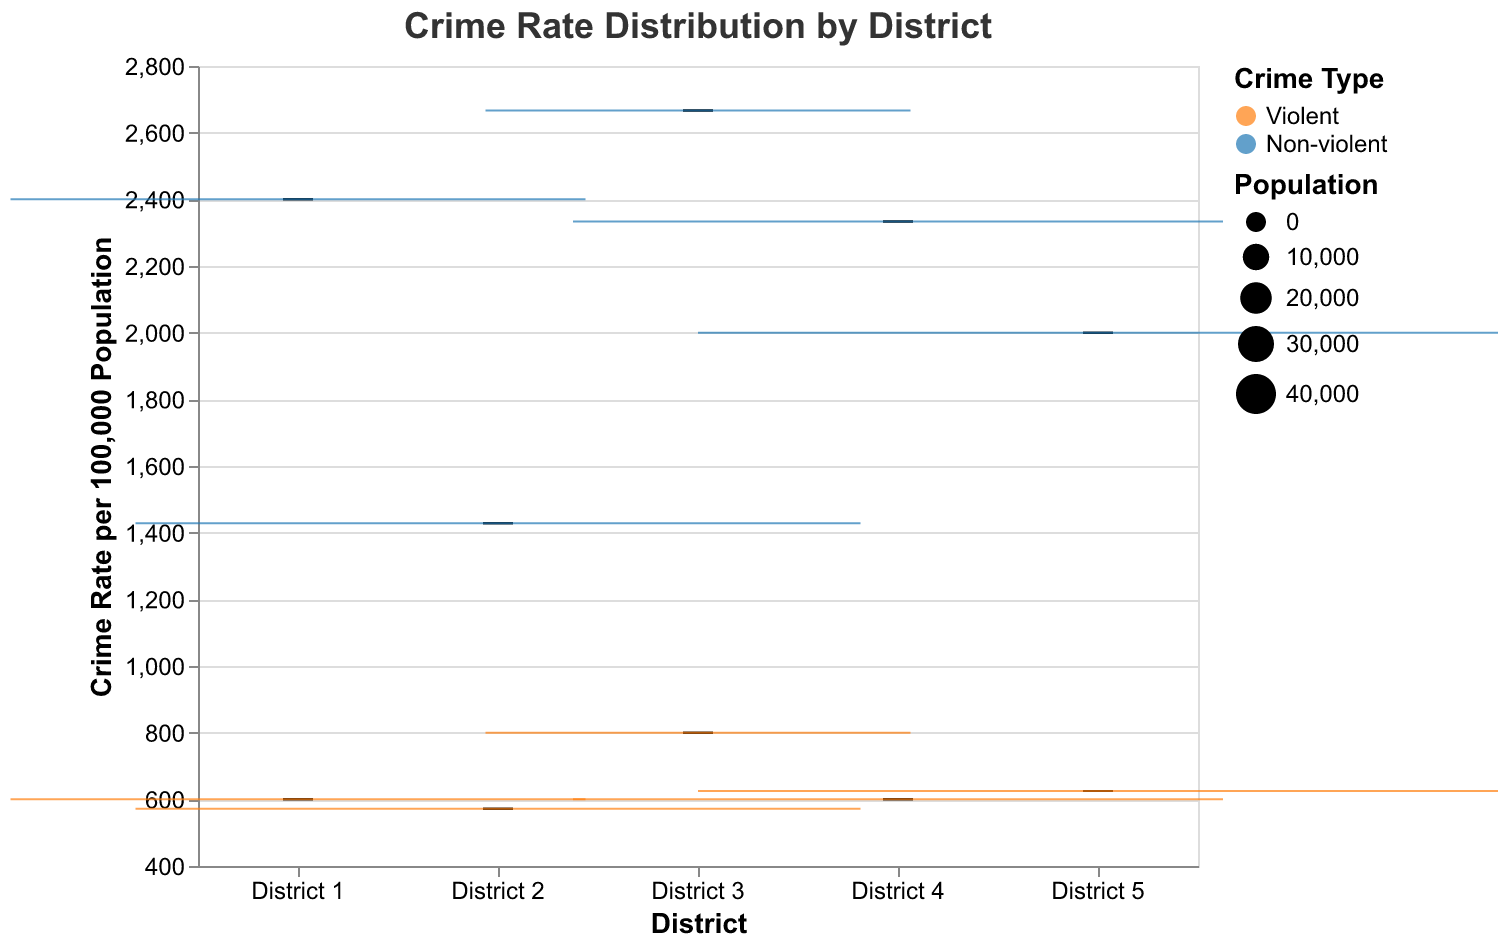What is the title of the figure? The title of the figure is provided at the top. It reads: "Crime Rate Distribution by District".
Answer: Crime Rate Distribution by District What are the two crime types represented by the colors in the figure? The colors represent two crime types. Orange (#ff7f0e) represents Violent crimes and Blue (#1f77b4) represents Non-violent crimes.
Answer: Violent and Non-violent Which district has the highest violent crime rate per 100,000 population? By examining the orange box plots for violent crimes, District 5 clearly has the highest median violent crime rate compared to other districts.
Answer: District 5 What is the range of the crime rate for non-violent crimes in District 4? The whiskers of the blue box plot for District 4 show the range. The crime rates range approximately from 2,100 to 2,500 per 100,000 population.
Answer: 2,100 - 2,500 Which district has the largest population and how do we know? The size of the boxes represents the population. District 5 has the largest box, indicating the largest population.
Answer: District 5 What can you infer about the distribution of crime rates for violent crimes in District 2 compared to District 3? The orange box plot for violent crimes in District 2 is taller and more spread out compared to District 3, indicating a higher variability in crime rates in District 2.
Answer: District 2 has higher variability Among the districts, which has the smallest range of non-violent crime rates and how can you tell? By looking at the blue box plots, District 1 has the smallest range for non-violent crimes since its whiskers are the shortest.
Answer: District 1 For which district do the median violent and non-violent crime rates differ the most? Comparing the orange and blue median lines across districts, District 5 shows a significant difference between the median rates of violent and non-violent crimes.
Answer: District 5 How does the non-violent crime rate distribution in District 3 compare to District 1? The blue box plot for District 3 shows lower overall crime rates and a smaller interquartile range (IQR) compared to District 1, indicating lower and more consistent non-violent crime rates in District 3.
Answer: Lower and more consistent Are there any outliers visible in the non-violent crime rates, and if so, in which district? Outliers are marked by points outside the whiskers in the box plots. There are no outliers visible in the non-violent crime rates for any district in this figure.
Answer: No outliers 